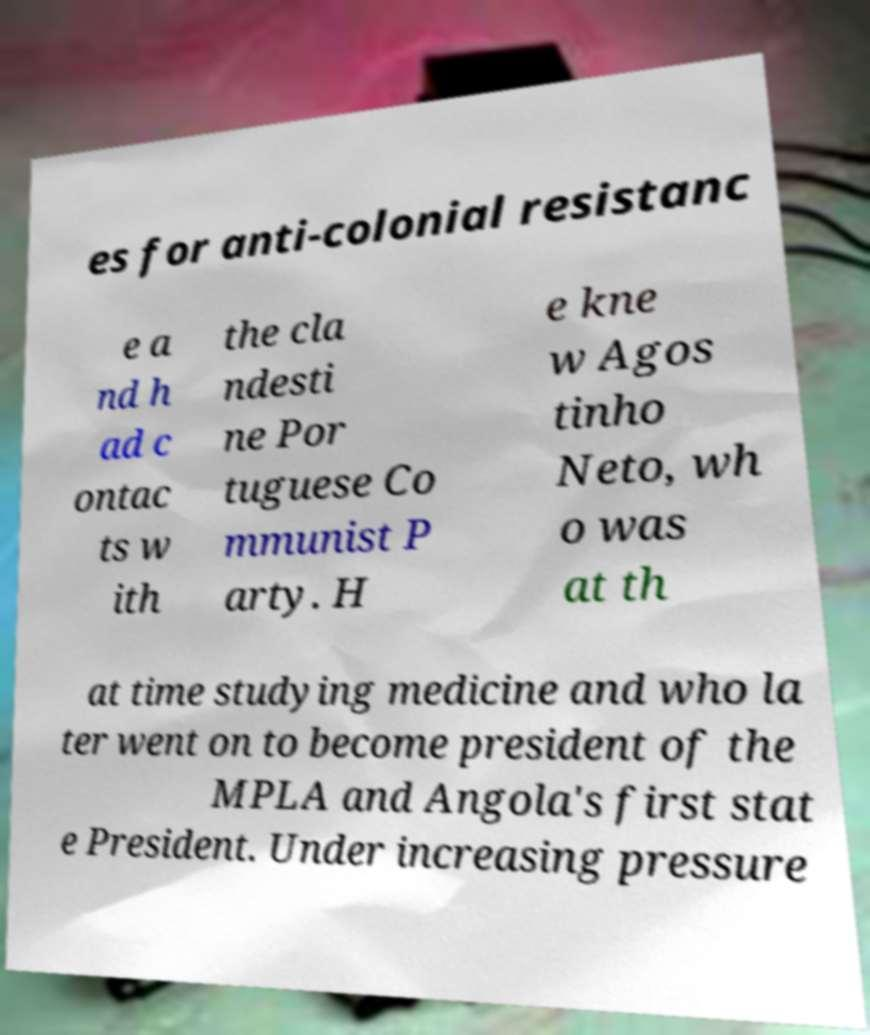Please identify and transcribe the text found in this image. es for anti-colonial resistanc e a nd h ad c ontac ts w ith the cla ndesti ne Por tuguese Co mmunist P arty. H e kne w Agos tinho Neto, wh o was at th at time studying medicine and who la ter went on to become president of the MPLA and Angola's first stat e President. Under increasing pressure 